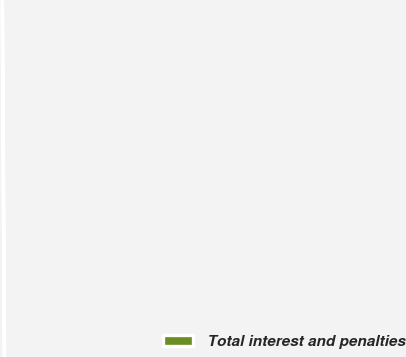Convert chart to OTSL. <chart><loc_0><loc_0><loc_500><loc_500><pie_chart><fcel>Total interest and penalties<nl><fcel>100.0%<nl></chart> 